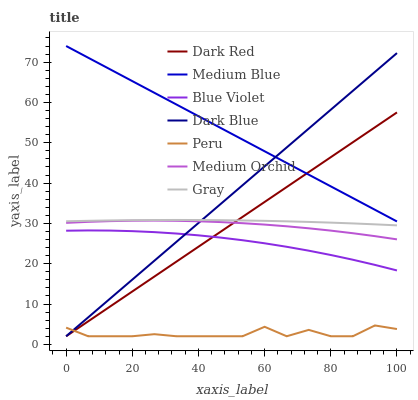Does Peru have the minimum area under the curve?
Answer yes or no. Yes. Does Medium Blue have the maximum area under the curve?
Answer yes or no. Yes. Does Dark Red have the minimum area under the curve?
Answer yes or no. No. Does Dark Red have the maximum area under the curve?
Answer yes or no. No. Is Dark Blue the smoothest?
Answer yes or no. Yes. Is Peru the roughest?
Answer yes or no. Yes. Is Dark Red the smoothest?
Answer yes or no. No. Is Dark Red the roughest?
Answer yes or no. No. Does Dark Red have the lowest value?
Answer yes or no. Yes. Does Medium Orchid have the lowest value?
Answer yes or no. No. Does Medium Blue have the highest value?
Answer yes or no. Yes. Does Dark Red have the highest value?
Answer yes or no. No. Is Gray less than Medium Blue?
Answer yes or no. Yes. Is Gray greater than Peru?
Answer yes or no. Yes. Does Medium Orchid intersect Dark Blue?
Answer yes or no. Yes. Is Medium Orchid less than Dark Blue?
Answer yes or no. No. Is Medium Orchid greater than Dark Blue?
Answer yes or no. No. Does Gray intersect Medium Blue?
Answer yes or no. No. 